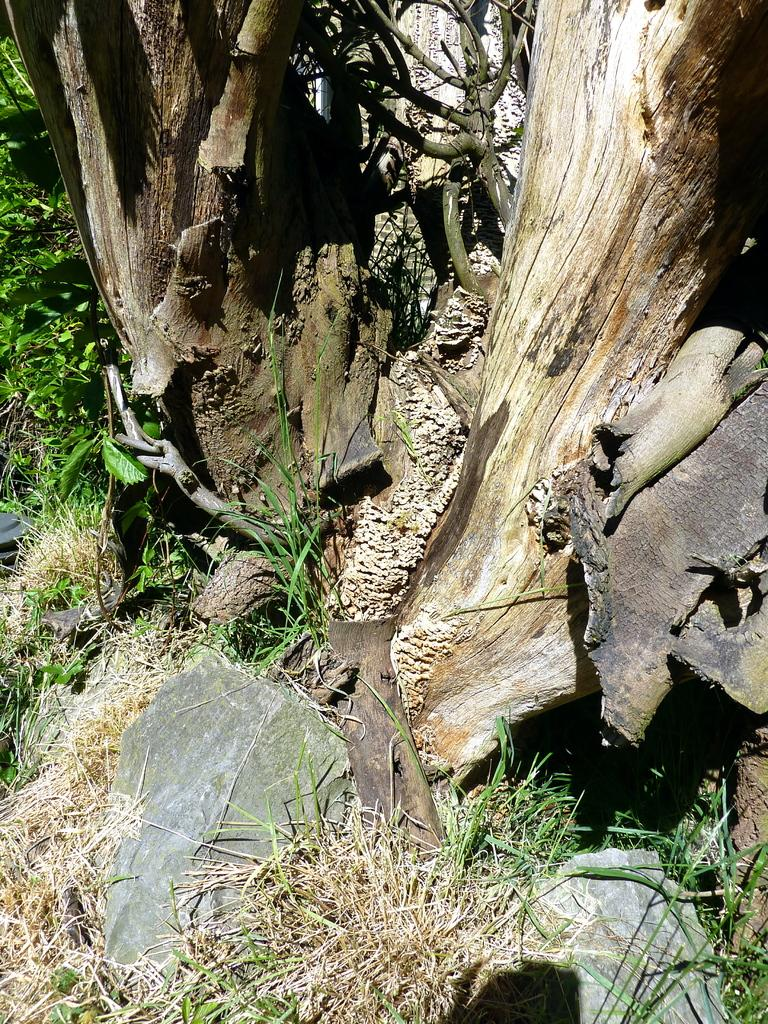What type of plant can be seen in the image? There is a tree in the image. What type of vegetation is at the bottom of the image? There is grass at the bottom of the image. What other object can be seen in the image? There is a rock in the image. What type of school can be seen in the image? There is no school present in the image; it features a tree, grass, and a rock. What part of the human body is visible in the image? There are no human body parts visible in the image. 